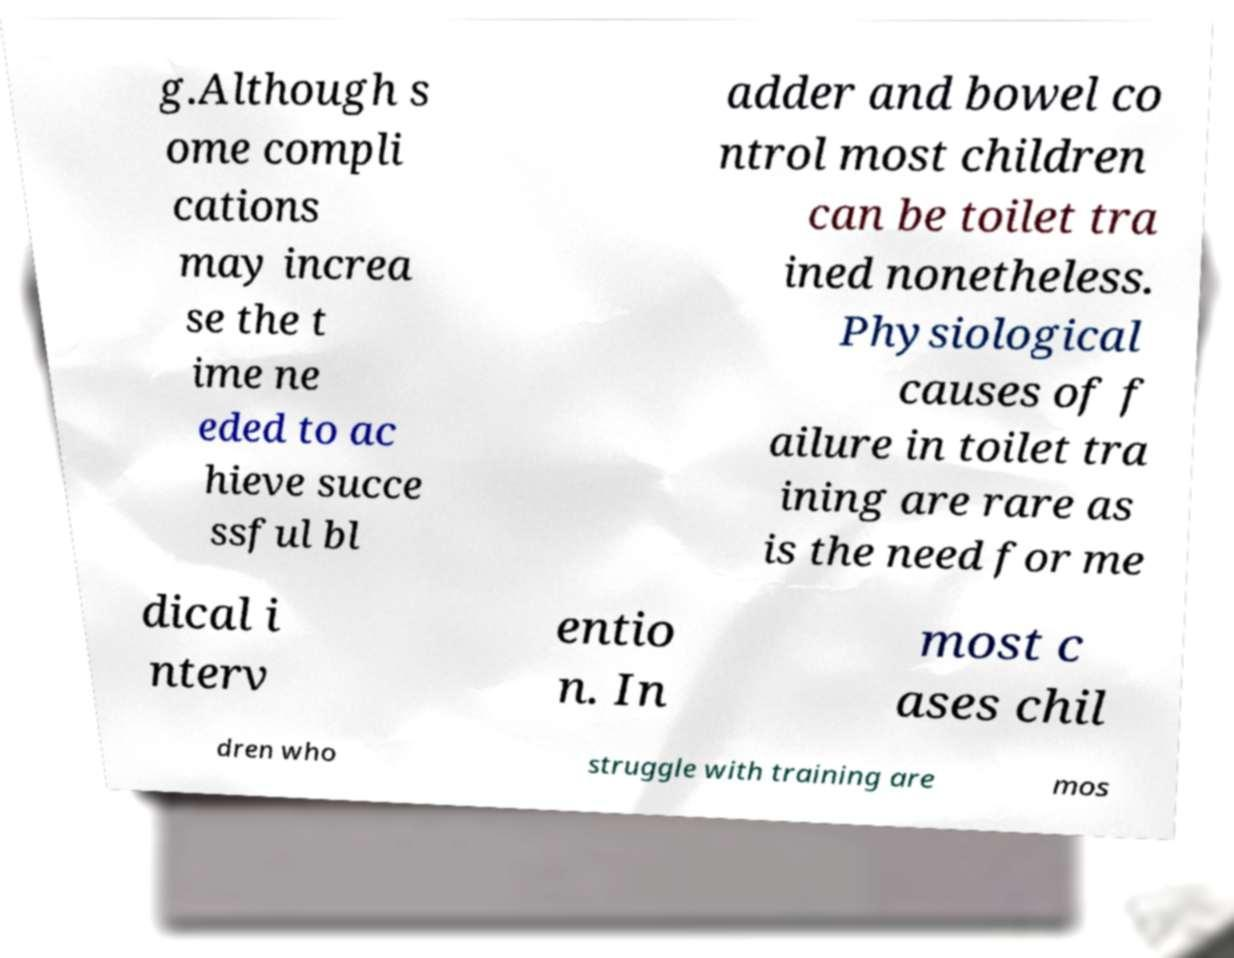Could you extract and type out the text from this image? g.Although s ome compli cations may increa se the t ime ne eded to ac hieve succe ssful bl adder and bowel co ntrol most children can be toilet tra ined nonetheless. Physiological causes of f ailure in toilet tra ining are rare as is the need for me dical i nterv entio n. In most c ases chil dren who struggle with training are mos 